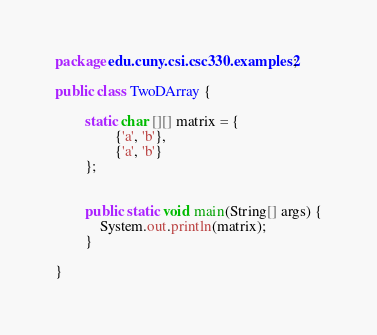<code> <loc_0><loc_0><loc_500><loc_500><_Java_>package edu.cuny.csi.csc330.examples2;

public class TwoDArray {

		static char [][] matrix = { 
				{'a', 'b'},
				{'a', 'b'}
		}; 
		
		
		public static void main(String[] args) {
			System.out.println(matrix);
		}

}
</code> 